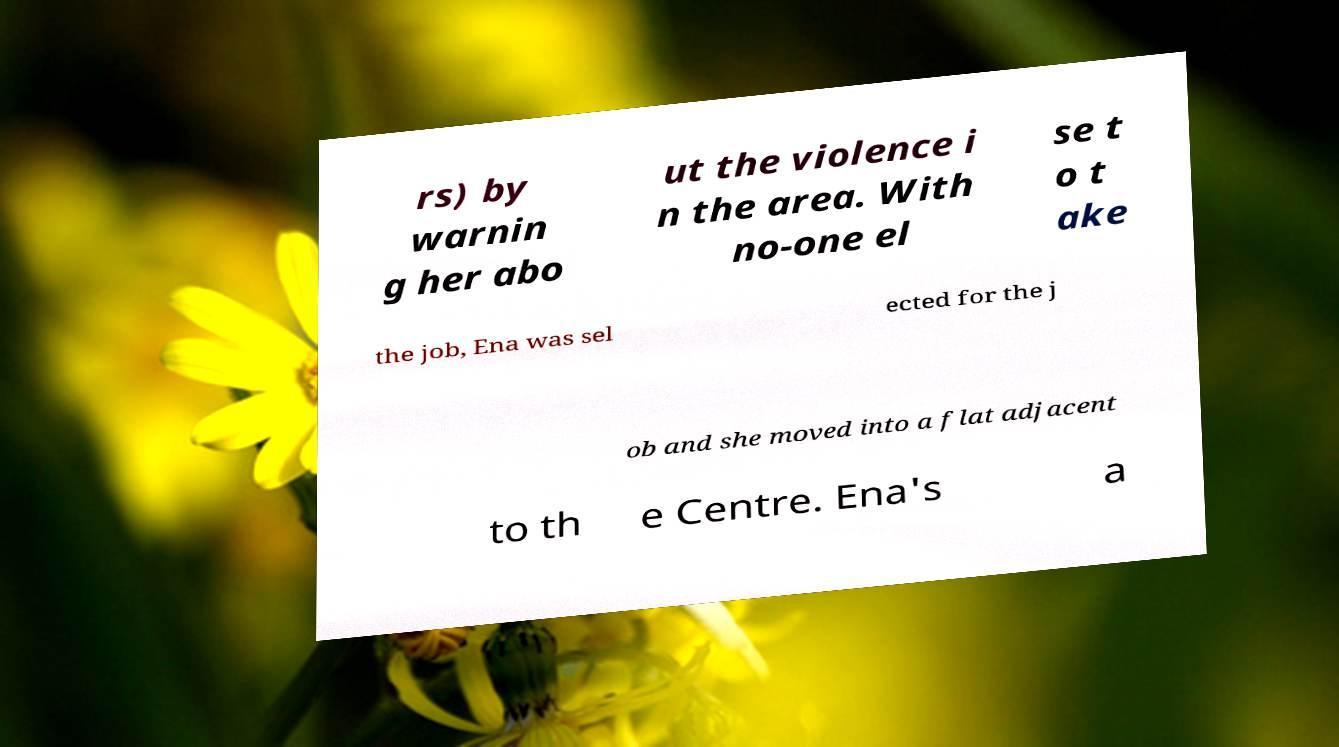What messages or text are displayed in this image? I need them in a readable, typed format. rs) by warnin g her abo ut the violence i n the area. With no-one el se t o t ake the job, Ena was sel ected for the j ob and she moved into a flat adjacent to th e Centre. Ena's a 